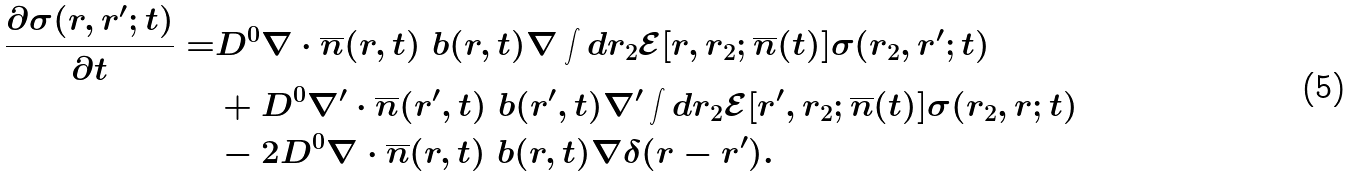Convert formula to latex. <formula><loc_0><loc_0><loc_500><loc_500>\frac { \partial \sigma ( r , r ^ { \prime } ; t ) } { \partial t } = & D ^ { 0 } { \nabla } \cdot \overline { n } ( r , t ) \ b ( r , t ) \nabla \int d r _ { 2 } \mathcal { E } [ r , r _ { 2 } ; \overline { n } ( t ) ] \sigma ( r _ { 2 } , r ^ { \prime } ; t ) \\ & + D ^ { 0 } { \nabla } ^ { \prime } \cdot \overline { n } ( r ^ { \prime } , t ) \ b ( r ^ { \prime } , t ) \nabla ^ { \prime } \int d r _ { 2 } \mathcal { E } [ r ^ { \prime } , r _ { 2 } ; \overline { n } ( t ) ] \sigma ( r _ { 2 } , r ; t ) \\ & - 2 D ^ { 0 } { \nabla } \cdot \overline { n } ( r , t ) \ b ( r , t ) \nabla \delta ( r - r ^ { \prime } ) .</formula> 